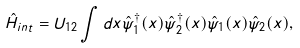Convert formula to latex. <formula><loc_0><loc_0><loc_500><loc_500>\hat { H } _ { i n t } = U _ { 1 2 } \int d { x } \hat { \psi } ^ { \dagger } _ { 1 } ( { x } ) \hat { \psi } ^ { \dagger } _ { 2 } ( { x } ) \hat { \psi } _ { 1 } ( { x } ) \hat { \psi } _ { 2 } ( { x } ) ,</formula> 